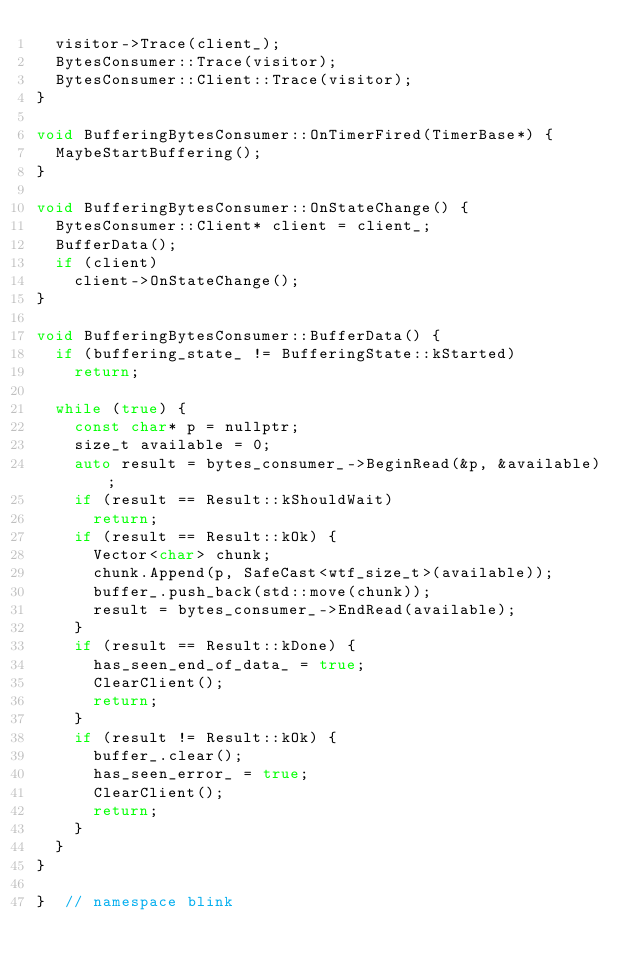Convert code to text. <code><loc_0><loc_0><loc_500><loc_500><_C++_>  visitor->Trace(client_);
  BytesConsumer::Trace(visitor);
  BytesConsumer::Client::Trace(visitor);
}

void BufferingBytesConsumer::OnTimerFired(TimerBase*) {
  MaybeStartBuffering();
}

void BufferingBytesConsumer::OnStateChange() {
  BytesConsumer::Client* client = client_;
  BufferData();
  if (client)
    client->OnStateChange();
}

void BufferingBytesConsumer::BufferData() {
  if (buffering_state_ != BufferingState::kStarted)
    return;

  while (true) {
    const char* p = nullptr;
    size_t available = 0;
    auto result = bytes_consumer_->BeginRead(&p, &available);
    if (result == Result::kShouldWait)
      return;
    if (result == Result::kOk) {
      Vector<char> chunk;
      chunk.Append(p, SafeCast<wtf_size_t>(available));
      buffer_.push_back(std::move(chunk));
      result = bytes_consumer_->EndRead(available);
    }
    if (result == Result::kDone) {
      has_seen_end_of_data_ = true;
      ClearClient();
      return;
    }
    if (result != Result::kOk) {
      buffer_.clear();
      has_seen_error_ = true;
      ClearClient();
      return;
    }
  }
}

}  // namespace blink
</code> 